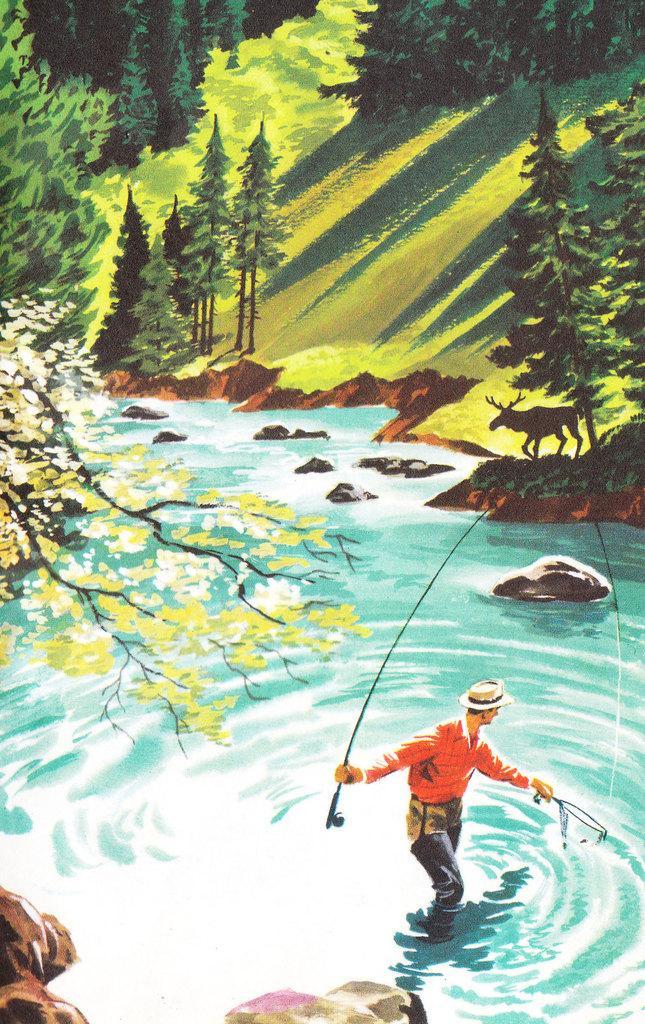In one or two sentences, can you explain what this image depicts? In this image we can see a painting. Top of the image grassy land and trees are present. Bottom of the image one man is standing by holding fishing net in his hand in the water. Bottom of the image some rocks are present. 